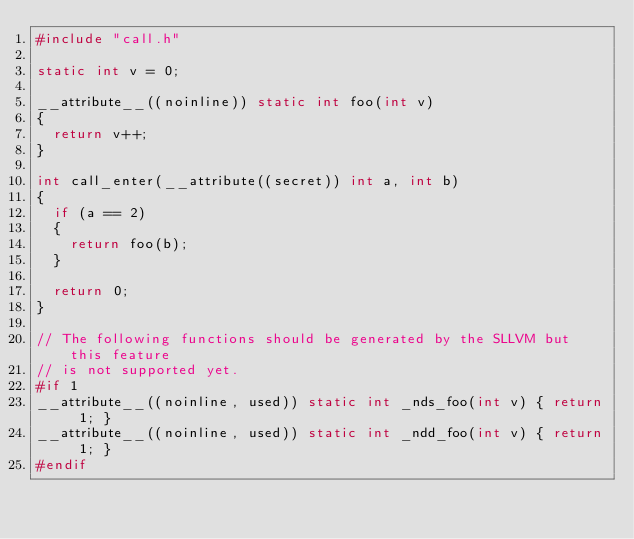Convert code to text. <code><loc_0><loc_0><loc_500><loc_500><_C_>#include "call.h"

static int v = 0;

__attribute__((noinline)) static int foo(int v)
{
  return v++;
}

int call_enter(__attribute((secret)) int a, int b)
{
  if (a == 2)
  {
    return foo(b);
  }

  return 0;
}

// The following functions should be generated by the SLLVM but this feature
// is not supported yet.
#if 1
__attribute__((noinline, used)) static int _nds_foo(int v) { return 1; }
__attribute__((noinline, used)) static int _ndd_foo(int v) { return 1; }
#endif

</code> 